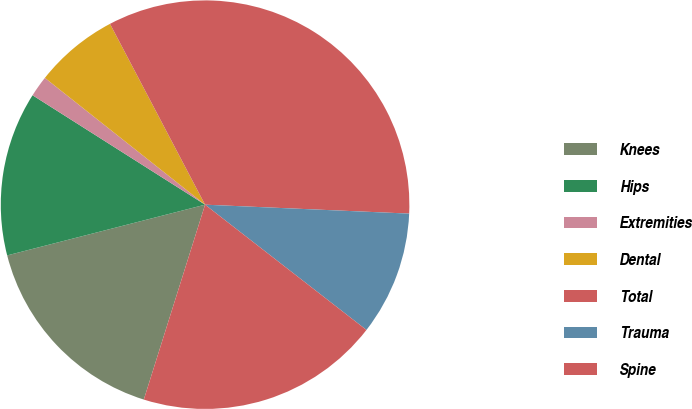Convert chart. <chart><loc_0><loc_0><loc_500><loc_500><pie_chart><fcel>Knees<fcel>Hips<fcel>Extremities<fcel>Dental<fcel>Total<fcel>Trauma<fcel>Spine<nl><fcel>16.16%<fcel>12.99%<fcel>1.66%<fcel>6.64%<fcel>33.4%<fcel>9.81%<fcel>19.34%<nl></chart> 